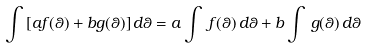Convert formula to latex. <formula><loc_0><loc_0><loc_500><loc_500>\int \, [ a f ( \theta ) + b g ( \theta ) ] \, d \theta = a \int \, f ( \theta ) \, d \theta + b \int \, g ( \theta ) \, d \theta</formula> 